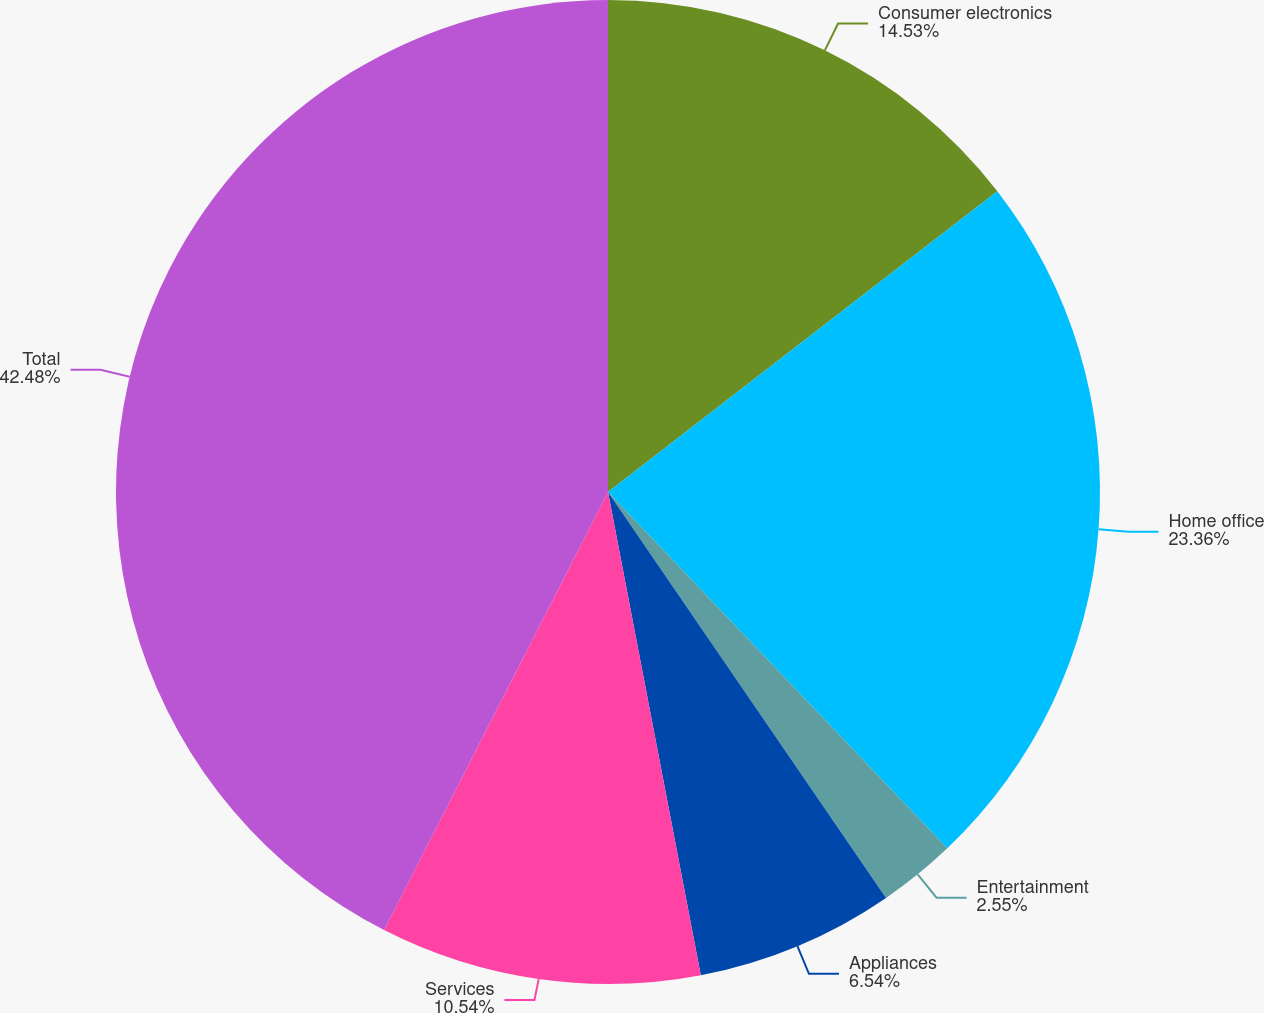Convert chart. <chart><loc_0><loc_0><loc_500><loc_500><pie_chart><fcel>Consumer electronics<fcel>Home office<fcel>Entertainment<fcel>Appliances<fcel>Services<fcel>Total<nl><fcel>14.53%<fcel>23.36%<fcel>2.55%<fcel>6.54%<fcel>10.54%<fcel>42.48%<nl></chart> 